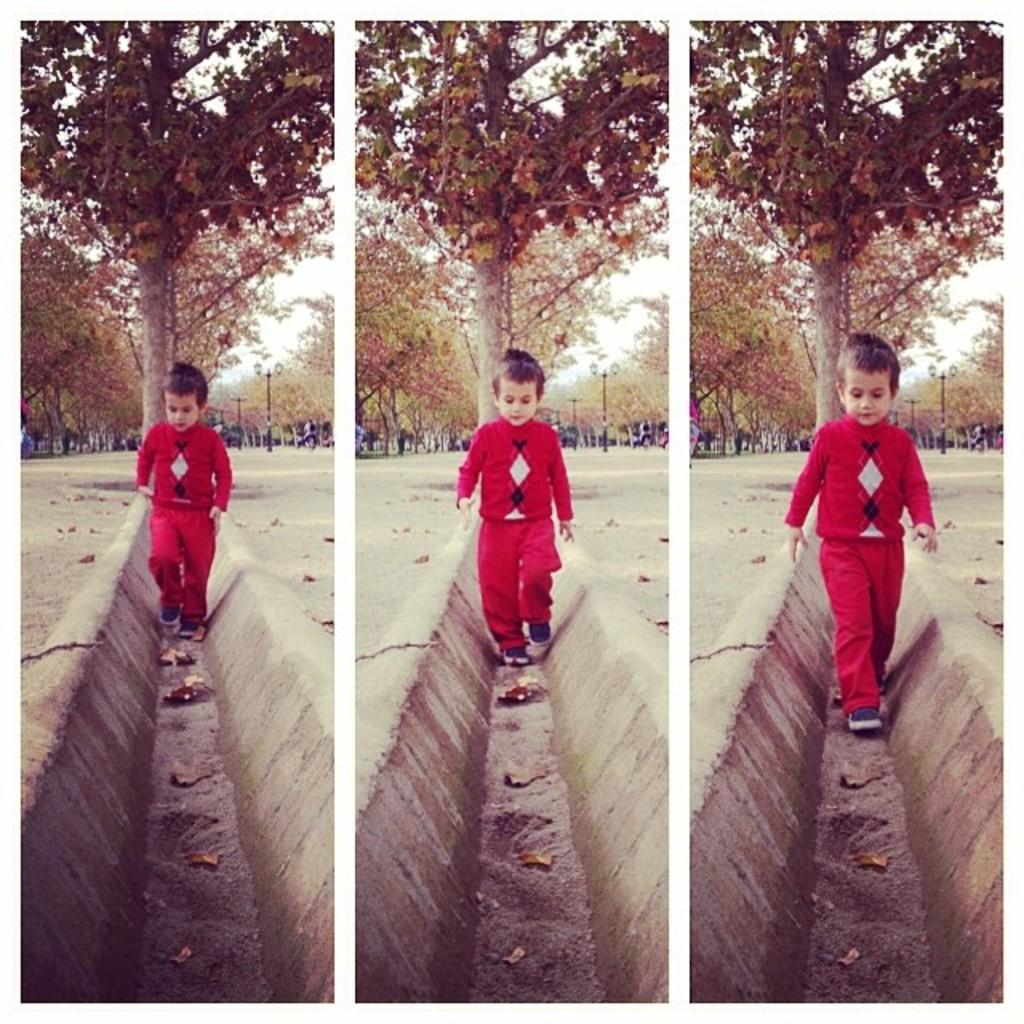How many pictures are in the image? There are three pictures in the image. What are the kids in the pictures doing? In each picture, there is a kid walking. What can be seen in the background of the pictures? There are trees and persons in the background of the pictures. What is present on the ground in the pictures? Dry leaves are present on the ground in the pictures. What type of light can be seen in the pictures? There is no specific mention of light in the provided facts, so it cannot be determined what type of light is present in the pictures. 